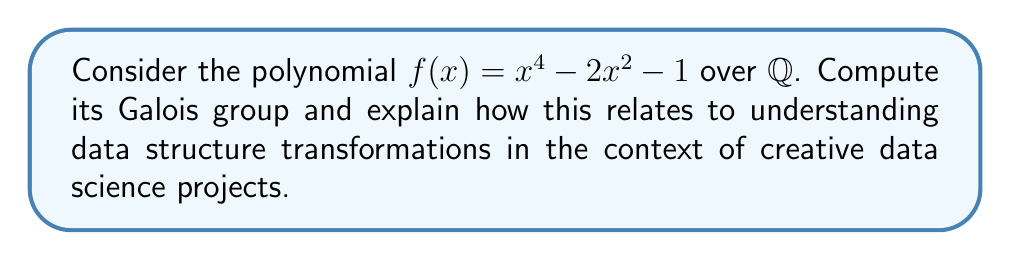Can you answer this question? 1) First, let's find the roots of $f(x)$:
   $f(x) = x^4 - 2x^2 - 1 = (x^2 - \sqrt{3})(x^2 + \sqrt{3})$
   Roots are: $\pm\sqrt{\sqrt{3}}$ and $\pm i\sqrt{\sqrt{3}}$

2) The splitting field of $f(x)$ over $\mathbb{Q}$ is $\mathbb{Q}(\sqrt{\sqrt{3}}, i)$

3) To find the Galois group, we need to consider the automorphisms of this splitting field that fix $\mathbb{Q}$:

   a) Identity: $id(\sqrt{\sqrt{3}}) = \sqrt{\sqrt{3}}$, $id(i) = i$
   b) $\sigma: \sqrt{\sqrt{3}} \mapsto -\sqrt{\sqrt{3}}$, $i \mapsto i$
   c) $\tau: \sqrt{\sqrt{3}} \mapsto \sqrt{\sqrt{3}}$, $i \mapsto -i$
   d) $\sigma\tau: \sqrt{\sqrt{3}} \mapsto -\sqrt{\sqrt{3}}$, $i \mapsto -i$

4) These four automorphisms form a group isomorphic to the Klein four-group $V_4 \cong \mathbb{Z}_2 \times \mathbb{Z}_2$

5) In the context of data science and creative projects, this Galois group structure can be interpreted as follows:

   - The four elements of $V_4$ represent four possible transformations of a data structure.
   - The identity transformation (no change) corresponds to $id$.
   - $\sigma$ could represent a transformation that inverts a numerical feature.
   - $\tau$ could represent a transformation that changes the sign of a complex-valued feature.
   - $\sigma\tau$ combines both transformations.

6) Understanding this group structure helps in designing reversible data transformations, which can be crucial in creative data visualization or generative art projects where data integrity and invertibility are important.
Answer: $V_4 \cong \mathbb{Z}_2 \times \mathbb{Z}_2$ 